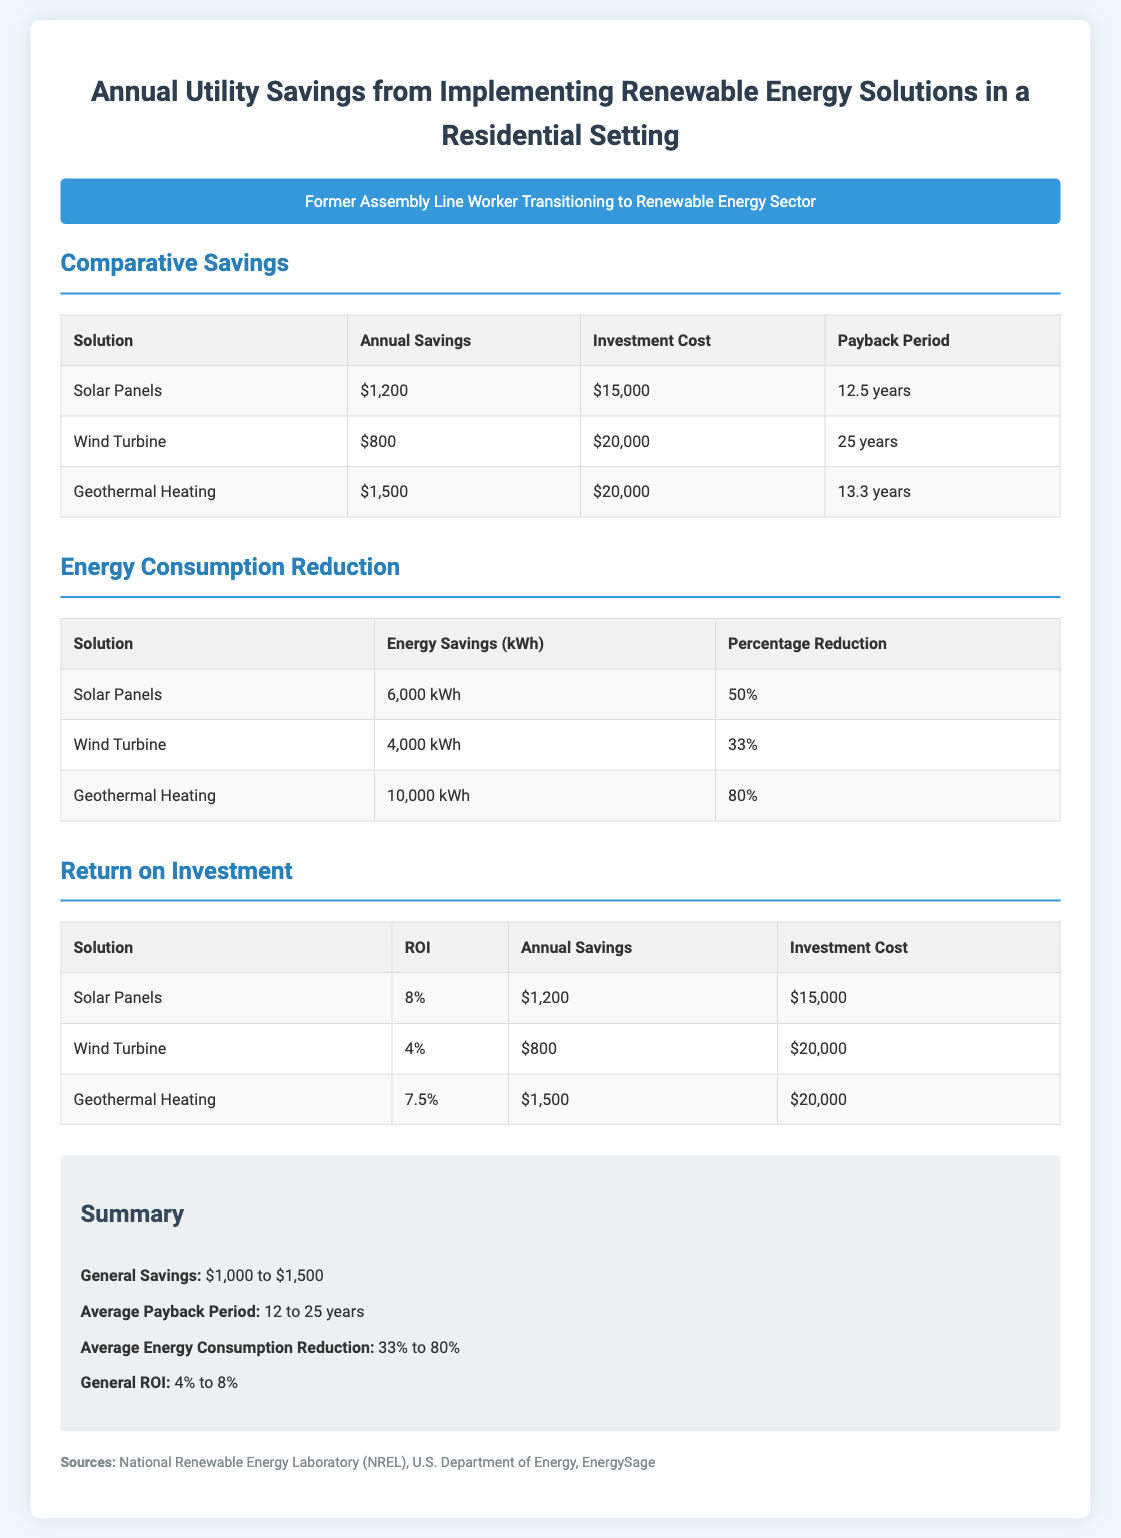What is the annual savings from solar panels? The annual savings for solar panels is provided in the comparative savings section of the document as $1,200.
Answer: $1,200 What is the payback period for a wind turbine? The payback period for a wind turbine is listed in the comparative savings section as 25 years.
Answer: 25 years How much energy is saved by geothermal heating? The energy savings for geothermal heating is stated in the energy consumption reduction section as 10,000 kWh.
Answer: 10,000 kWh What is the average ROI for renewable energy solutions? The average ROI can be derived from the general summary, which indicates a range between 4% to 8%.
Answer: 4% to 8% Which solution has the highest annual savings? Comparing the annual savings in the comparative savings section, geothermal heating has the highest at $1,500.
Answer: $1,500 What percentage reduction in energy consumption does solar panels achieve? The percentage reduction for solar panels is specified in the energy consumption reduction section as 50%.
Answer: 50% What is the investment cost associated with wind turbines? The investment cost for wind turbines is identified in the comparative savings section as $20,000.
Answer: $20,000 Which renewable energy solution has the shortest payback period? By examining the payback periods in the comparative savings section, solar panels have the shortest at 12.5 years.
Answer: 12.5 years 